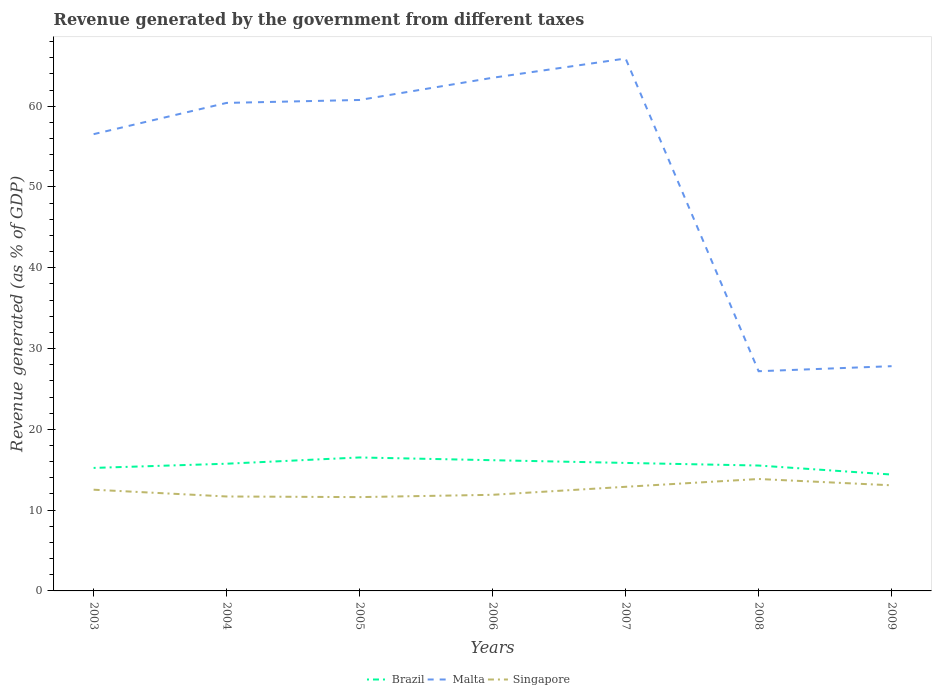How many different coloured lines are there?
Ensure brevity in your answer.  3. Does the line corresponding to Malta intersect with the line corresponding to Singapore?
Make the answer very short. No. Is the number of lines equal to the number of legend labels?
Offer a terse response. Yes. Across all years, what is the maximum revenue generated by the government in Singapore?
Ensure brevity in your answer.  11.61. In which year was the revenue generated by the government in Singapore maximum?
Provide a short and direct response. 2005. What is the total revenue generated by the government in Singapore in the graph?
Ensure brevity in your answer.  -0.96. What is the difference between the highest and the second highest revenue generated by the government in Malta?
Keep it short and to the point. 38.71. How many lines are there?
Your response must be concise. 3. How many years are there in the graph?
Your response must be concise. 7. Are the values on the major ticks of Y-axis written in scientific E-notation?
Provide a succinct answer. No. Does the graph contain grids?
Keep it short and to the point. No. What is the title of the graph?
Offer a terse response. Revenue generated by the government from different taxes. Does "Jamaica" appear as one of the legend labels in the graph?
Make the answer very short. No. What is the label or title of the Y-axis?
Ensure brevity in your answer.  Revenue generated (as % of GDP). What is the Revenue generated (as % of GDP) of Brazil in 2003?
Provide a succinct answer. 15.23. What is the Revenue generated (as % of GDP) in Malta in 2003?
Your answer should be compact. 56.54. What is the Revenue generated (as % of GDP) in Singapore in 2003?
Your answer should be very brief. 12.53. What is the Revenue generated (as % of GDP) in Brazil in 2004?
Your answer should be compact. 15.75. What is the Revenue generated (as % of GDP) in Malta in 2004?
Offer a terse response. 60.41. What is the Revenue generated (as % of GDP) in Singapore in 2004?
Keep it short and to the point. 11.69. What is the Revenue generated (as % of GDP) of Brazil in 2005?
Keep it short and to the point. 16.52. What is the Revenue generated (as % of GDP) of Malta in 2005?
Your answer should be very brief. 60.77. What is the Revenue generated (as % of GDP) of Singapore in 2005?
Your response must be concise. 11.61. What is the Revenue generated (as % of GDP) in Brazil in 2006?
Keep it short and to the point. 16.18. What is the Revenue generated (as % of GDP) of Malta in 2006?
Offer a terse response. 63.52. What is the Revenue generated (as % of GDP) of Singapore in 2006?
Offer a terse response. 11.9. What is the Revenue generated (as % of GDP) in Brazil in 2007?
Ensure brevity in your answer.  15.84. What is the Revenue generated (as % of GDP) in Malta in 2007?
Your answer should be very brief. 65.9. What is the Revenue generated (as % of GDP) in Singapore in 2007?
Offer a very short reply. 12.89. What is the Revenue generated (as % of GDP) in Brazil in 2008?
Ensure brevity in your answer.  15.52. What is the Revenue generated (as % of GDP) in Malta in 2008?
Your response must be concise. 27.19. What is the Revenue generated (as % of GDP) of Singapore in 2008?
Make the answer very short. 13.85. What is the Revenue generated (as % of GDP) of Brazil in 2009?
Provide a short and direct response. 14.4. What is the Revenue generated (as % of GDP) of Malta in 2009?
Your answer should be compact. 27.82. What is the Revenue generated (as % of GDP) of Singapore in 2009?
Your answer should be very brief. 13.07. Across all years, what is the maximum Revenue generated (as % of GDP) in Brazil?
Keep it short and to the point. 16.52. Across all years, what is the maximum Revenue generated (as % of GDP) in Malta?
Your answer should be very brief. 65.9. Across all years, what is the maximum Revenue generated (as % of GDP) of Singapore?
Your response must be concise. 13.85. Across all years, what is the minimum Revenue generated (as % of GDP) of Brazil?
Your answer should be compact. 14.4. Across all years, what is the minimum Revenue generated (as % of GDP) in Malta?
Keep it short and to the point. 27.19. Across all years, what is the minimum Revenue generated (as % of GDP) of Singapore?
Keep it short and to the point. 11.61. What is the total Revenue generated (as % of GDP) of Brazil in the graph?
Your response must be concise. 109.44. What is the total Revenue generated (as % of GDP) of Malta in the graph?
Make the answer very short. 362.15. What is the total Revenue generated (as % of GDP) of Singapore in the graph?
Offer a very short reply. 87.54. What is the difference between the Revenue generated (as % of GDP) in Brazil in 2003 and that in 2004?
Provide a short and direct response. -0.52. What is the difference between the Revenue generated (as % of GDP) in Malta in 2003 and that in 2004?
Give a very brief answer. -3.87. What is the difference between the Revenue generated (as % of GDP) of Singapore in 2003 and that in 2004?
Keep it short and to the point. 0.84. What is the difference between the Revenue generated (as % of GDP) in Brazil in 2003 and that in 2005?
Provide a succinct answer. -1.29. What is the difference between the Revenue generated (as % of GDP) of Malta in 2003 and that in 2005?
Offer a very short reply. -4.23. What is the difference between the Revenue generated (as % of GDP) of Singapore in 2003 and that in 2005?
Your response must be concise. 0.92. What is the difference between the Revenue generated (as % of GDP) in Brazil in 2003 and that in 2006?
Provide a short and direct response. -0.95. What is the difference between the Revenue generated (as % of GDP) in Malta in 2003 and that in 2006?
Your answer should be very brief. -6.98. What is the difference between the Revenue generated (as % of GDP) of Singapore in 2003 and that in 2006?
Your response must be concise. 0.63. What is the difference between the Revenue generated (as % of GDP) in Brazil in 2003 and that in 2007?
Give a very brief answer. -0.62. What is the difference between the Revenue generated (as % of GDP) in Malta in 2003 and that in 2007?
Your answer should be very brief. -9.36. What is the difference between the Revenue generated (as % of GDP) in Singapore in 2003 and that in 2007?
Offer a terse response. -0.36. What is the difference between the Revenue generated (as % of GDP) in Brazil in 2003 and that in 2008?
Offer a very short reply. -0.29. What is the difference between the Revenue generated (as % of GDP) in Malta in 2003 and that in 2008?
Offer a terse response. 29.34. What is the difference between the Revenue generated (as % of GDP) of Singapore in 2003 and that in 2008?
Ensure brevity in your answer.  -1.32. What is the difference between the Revenue generated (as % of GDP) of Brazil in 2003 and that in 2009?
Keep it short and to the point. 0.82. What is the difference between the Revenue generated (as % of GDP) of Malta in 2003 and that in 2009?
Keep it short and to the point. 28.72. What is the difference between the Revenue generated (as % of GDP) in Singapore in 2003 and that in 2009?
Your response must be concise. -0.54. What is the difference between the Revenue generated (as % of GDP) in Brazil in 2004 and that in 2005?
Provide a short and direct response. -0.78. What is the difference between the Revenue generated (as % of GDP) in Malta in 2004 and that in 2005?
Ensure brevity in your answer.  -0.36. What is the difference between the Revenue generated (as % of GDP) of Singapore in 2004 and that in 2005?
Your answer should be compact. 0.08. What is the difference between the Revenue generated (as % of GDP) of Brazil in 2004 and that in 2006?
Offer a terse response. -0.43. What is the difference between the Revenue generated (as % of GDP) of Malta in 2004 and that in 2006?
Ensure brevity in your answer.  -3.11. What is the difference between the Revenue generated (as % of GDP) of Singapore in 2004 and that in 2006?
Your response must be concise. -0.21. What is the difference between the Revenue generated (as % of GDP) in Brazil in 2004 and that in 2007?
Offer a terse response. -0.1. What is the difference between the Revenue generated (as % of GDP) in Malta in 2004 and that in 2007?
Ensure brevity in your answer.  -5.5. What is the difference between the Revenue generated (as % of GDP) of Singapore in 2004 and that in 2007?
Offer a terse response. -1.2. What is the difference between the Revenue generated (as % of GDP) in Brazil in 2004 and that in 2008?
Offer a terse response. 0.22. What is the difference between the Revenue generated (as % of GDP) in Malta in 2004 and that in 2008?
Your answer should be compact. 33.21. What is the difference between the Revenue generated (as % of GDP) of Singapore in 2004 and that in 2008?
Provide a succinct answer. -2.16. What is the difference between the Revenue generated (as % of GDP) of Brazil in 2004 and that in 2009?
Give a very brief answer. 1.34. What is the difference between the Revenue generated (as % of GDP) of Malta in 2004 and that in 2009?
Provide a short and direct response. 32.59. What is the difference between the Revenue generated (as % of GDP) of Singapore in 2004 and that in 2009?
Provide a short and direct response. -1.38. What is the difference between the Revenue generated (as % of GDP) of Brazil in 2005 and that in 2006?
Offer a terse response. 0.34. What is the difference between the Revenue generated (as % of GDP) of Malta in 2005 and that in 2006?
Your answer should be very brief. -2.75. What is the difference between the Revenue generated (as % of GDP) of Singapore in 2005 and that in 2006?
Offer a terse response. -0.29. What is the difference between the Revenue generated (as % of GDP) of Brazil in 2005 and that in 2007?
Offer a terse response. 0.68. What is the difference between the Revenue generated (as % of GDP) in Malta in 2005 and that in 2007?
Provide a short and direct response. -5.13. What is the difference between the Revenue generated (as % of GDP) of Singapore in 2005 and that in 2007?
Offer a very short reply. -1.28. What is the difference between the Revenue generated (as % of GDP) of Malta in 2005 and that in 2008?
Provide a succinct answer. 33.58. What is the difference between the Revenue generated (as % of GDP) in Singapore in 2005 and that in 2008?
Ensure brevity in your answer.  -2.24. What is the difference between the Revenue generated (as % of GDP) of Brazil in 2005 and that in 2009?
Provide a short and direct response. 2.12. What is the difference between the Revenue generated (as % of GDP) of Malta in 2005 and that in 2009?
Your response must be concise. 32.95. What is the difference between the Revenue generated (as % of GDP) in Singapore in 2005 and that in 2009?
Provide a succinct answer. -1.46. What is the difference between the Revenue generated (as % of GDP) in Brazil in 2006 and that in 2007?
Your answer should be very brief. 0.34. What is the difference between the Revenue generated (as % of GDP) of Malta in 2006 and that in 2007?
Keep it short and to the point. -2.38. What is the difference between the Revenue generated (as % of GDP) in Singapore in 2006 and that in 2007?
Your answer should be very brief. -0.99. What is the difference between the Revenue generated (as % of GDP) of Brazil in 2006 and that in 2008?
Your answer should be compact. 0.66. What is the difference between the Revenue generated (as % of GDP) of Malta in 2006 and that in 2008?
Keep it short and to the point. 36.32. What is the difference between the Revenue generated (as % of GDP) of Singapore in 2006 and that in 2008?
Your response must be concise. -1.96. What is the difference between the Revenue generated (as % of GDP) of Brazil in 2006 and that in 2009?
Make the answer very short. 1.78. What is the difference between the Revenue generated (as % of GDP) in Malta in 2006 and that in 2009?
Your response must be concise. 35.7. What is the difference between the Revenue generated (as % of GDP) of Singapore in 2006 and that in 2009?
Keep it short and to the point. -1.17. What is the difference between the Revenue generated (as % of GDP) in Brazil in 2007 and that in 2008?
Offer a terse response. 0.32. What is the difference between the Revenue generated (as % of GDP) in Malta in 2007 and that in 2008?
Offer a terse response. 38.71. What is the difference between the Revenue generated (as % of GDP) of Singapore in 2007 and that in 2008?
Provide a succinct answer. -0.96. What is the difference between the Revenue generated (as % of GDP) in Brazil in 2007 and that in 2009?
Your response must be concise. 1.44. What is the difference between the Revenue generated (as % of GDP) of Malta in 2007 and that in 2009?
Offer a terse response. 38.08. What is the difference between the Revenue generated (as % of GDP) of Singapore in 2007 and that in 2009?
Offer a very short reply. -0.18. What is the difference between the Revenue generated (as % of GDP) in Brazil in 2008 and that in 2009?
Make the answer very short. 1.12. What is the difference between the Revenue generated (as % of GDP) in Malta in 2008 and that in 2009?
Your response must be concise. -0.62. What is the difference between the Revenue generated (as % of GDP) in Singapore in 2008 and that in 2009?
Provide a succinct answer. 0.78. What is the difference between the Revenue generated (as % of GDP) of Brazil in 2003 and the Revenue generated (as % of GDP) of Malta in 2004?
Offer a terse response. -45.18. What is the difference between the Revenue generated (as % of GDP) of Brazil in 2003 and the Revenue generated (as % of GDP) of Singapore in 2004?
Provide a succinct answer. 3.54. What is the difference between the Revenue generated (as % of GDP) of Malta in 2003 and the Revenue generated (as % of GDP) of Singapore in 2004?
Offer a very short reply. 44.85. What is the difference between the Revenue generated (as % of GDP) in Brazil in 2003 and the Revenue generated (as % of GDP) in Malta in 2005?
Your response must be concise. -45.55. What is the difference between the Revenue generated (as % of GDP) in Brazil in 2003 and the Revenue generated (as % of GDP) in Singapore in 2005?
Give a very brief answer. 3.61. What is the difference between the Revenue generated (as % of GDP) in Malta in 2003 and the Revenue generated (as % of GDP) in Singapore in 2005?
Give a very brief answer. 44.93. What is the difference between the Revenue generated (as % of GDP) in Brazil in 2003 and the Revenue generated (as % of GDP) in Malta in 2006?
Give a very brief answer. -48.29. What is the difference between the Revenue generated (as % of GDP) of Brazil in 2003 and the Revenue generated (as % of GDP) of Singapore in 2006?
Keep it short and to the point. 3.33. What is the difference between the Revenue generated (as % of GDP) in Malta in 2003 and the Revenue generated (as % of GDP) in Singapore in 2006?
Provide a short and direct response. 44.64. What is the difference between the Revenue generated (as % of GDP) of Brazil in 2003 and the Revenue generated (as % of GDP) of Malta in 2007?
Offer a very short reply. -50.68. What is the difference between the Revenue generated (as % of GDP) of Brazil in 2003 and the Revenue generated (as % of GDP) of Singapore in 2007?
Offer a very short reply. 2.34. What is the difference between the Revenue generated (as % of GDP) of Malta in 2003 and the Revenue generated (as % of GDP) of Singapore in 2007?
Offer a very short reply. 43.65. What is the difference between the Revenue generated (as % of GDP) in Brazil in 2003 and the Revenue generated (as % of GDP) in Malta in 2008?
Offer a terse response. -11.97. What is the difference between the Revenue generated (as % of GDP) in Brazil in 2003 and the Revenue generated (as % of GDP) in Singapore in 2008?
Your answer should be very brief. 1.37. What is the difference between the Revenue generated (as % of GDP) of Malta in 2003 and the Revenue generated (as % of GDP) of Singapore in 2008?
Your answer should be very brief. 42.69. What is the difference between the Revenue generated (as % of GDP) in Brazil in 2003 and the Revenue generated (as % of GDP) in Malta in 2009?
Provide a succinct answer. -12.59. What is the difference between the Revenue generated (as % of GDP) in Brazil in 2003 and the Revenue generated (as % of GDP) in Singapore in 2009?
Your answer should be very brief. 2.15. What is the difference between the Revenue generated (as % of GDP) of Malta in 2003 and the Revenue generated (as % of GDP) of Singapore in 2009?
Your answer should be compact. 43.47. What is the difference between the Revenue generated (as % of GDP) in Brazil in 2004 and the Revenue generated (as % of GDP) in Malta in 2005?
Give a very brief answer. -45.03. What is the difference between the Revenue generated (as % of GDP) in Brazil in 2004 and the Revenue generated (as % of GDP) in Singapore in 2005?
Offer a very short reply. 4.13. What is the difference between the Revenue generated (as % of GDP) of Malta in 2004 and the Revenue generated (as % of GDP) of Singapore in 2005?
Offer a very short reply. 48.79. What is the difference between the Revenue generated (as % of GDP) in Brazil in 2004 and the Revenue generated (as % of GDP) in Malta in 2006?
Your response must be concise. -47.77. What is the difference between the Revenue generated (as % of GDP) of Brazil in 2004 and the Revenue generated (as % of GDP) of Singapore in 2006?
Give a very brief answer. 3.85. What is the difference between the Revenue generated (as % of GDP) in Malta in 2004 and the Revenue generated (as % of GDP) in Singapore in 2006?
Give a very brief answer. 48.51. What is the difference between the Revenue generated (as % of GDP) of Brazil in 2004 and the Revenue generated (as % of GDP) of Malta in 2007?
Make the answer very short. -50.16. What is the difference between the Revenue generated (as % of GDP) in Brazil in 2004 and the Revenue generated (as % of GDP) in Singapore in 2007?
Your response must be concise. 2.86. What is the difference between the Revenue generated (as % of GDP) in Malta in 2004 and the Revenue generated (as % of GDP) in Singapore in 2007?
Give a very brief answer. 47.52. What is the difference between the Revenue generated (as % of GDP) of Brazil in 2004 and the Revenue generated (as % of GDP) of Malta in 2008?
Your response must be concise. -11.45. What is the difference between the Revenue generated (as % of GDP) in Brazil in 2004 and the Revenue generated (as % of GDP) in Singapore in 2008?
Your response must be concise. 1.89. What is the difference between the Revenue generated (as % of GDP) in Malta in 2004 and the Revenue generated (as % of GDP) in Singapore in 2008?
Ensure brevity in your answer.  46.55. What is the difference between the Revenue generated (as % of GDP) in Brazil in 2004 and the Revenue generated (as % of GDP) in Malta in 2009?
Your answer should be compact. -12.07. What is the difference between the Revenue generated (as % of GDP) of Brazil in 2004 and the Revenue generated (as % of GDP) of Singapore in 2009?
Offer a terse response. 2.67. What is the difference between the Revenue generated (as % of GDP) of Malta in 2004 and the Revenue generated (as % of GDP) of Singapore in 2009?
Provide a succinct answer. 47.33. What is the difference between the Revenue generated (as % of GDP) of Brazil in 2005 and the Revenue generated (as % of GDP) of Malta in 2006?
Provide a succinct answer. -47. What is the difference between the Revenue generated (as % of GDP) in Brazil in 2005 and the Revenue generated (as % of GDP) in Singapore in 2006?
Provide a succinct answer. 4.62. What is the difference between the Revenue generated (as % of GDP) of Malta in 2005 and the Revenue generated (as % of GDP) of Singapore in 2006?
Your response must be concise. 48.87. What is the difference between the Revenue generated (as % of GDP) in Brazil in 2005 and the Revenue generated (as % of GDP) in Malta in 2007?
Offer a very short reply. -49.38. What is the difference between the Revenue generated (as % of GDP) in Brazil in 2005 and the Revenue generated (as % of GDP) in Singapore in 2007?
Your answer should be very brief. 3.63. What is the difference between the Revenue generated (as % of GDP) of Malta in 2005 and the Revenue generated (as % of GDP) of Singapore in 2007?
Provide a short and direct response. 47.88. What is the difference between the Revenue generated (as % of GDP) of Brazil in 2005 and the Revenue generated (as % of GDP) of Malta in 2008?
Make the answer very short. -10.67. What is the difference between the Revenue generated (as % of GDP) in Brazil in 2005 and the Revenue generated (as % of GDP) in Singapore in 2008?
Make the answer very short. 2.67. What is the difference between the Revenue generated (as % of GDP) of Malta in 2005 and the Revenue generated (as % of GDP) of Singapore in 2008?
Your response must be concise. 46.92. What is the difference between the Revenue generated (as % of GDP) of Brazil in 2005 and the Revenue generated (as % of GDP) of Malta in 2009?
Provide a short and direct response. -11.3. What is the difference between the Revenue generated (as % of GDP) of Brazil in 2005 and the Revenue generated (as % of GDP) of Singapore in 2009?
Make the answer very short. 3.45. What is the difference between the Revenue generated (as % of GDP) of Malta in 2005 and the Revenue generated (as % of GDP) of Singapore in 2009?
Your response must be concise. 47.7. What is the difference between the Revenue generated (as % of GDP) of Brazil in 2006 and the Revenue generated (as % of GDP) of Malta in 2007?
Your answer should be compact. -49.72. What is the difference between the Revenue generated (as % of GDP) in Brazil in 2006 and the Revenue generated (as % of GDP) in Singapore in 2007?
Ensure brevity in your answer.  3.29. What is the difference between the Revenue generated (as % of GDP) in Malta in 2006 and the Revenue generated (as % of GDP) in Singapore in 2007?
Provide a short and direct response. 50.63. What is the difference between the Revenue generated (as % of GDP) in Brazil in 2006 and the Revenue generated (as % of GDP) in Malta in 2008?
Your answer should be very brief. -11.01. What is the difference between the Revenue generated (as % of GDP) of Brazil in 2006 and the Revenue generated (as % of GDP) of Singapore in 2008?
Ensure brevity in your answer.  2.33. What is the difference between the Revenue generated (as % of GDP) in Malta in 2006 and the Revenue generated (as % of GDP) in Singapore in 2008?
Offer a very short reply. 49.66. What is the difference between the Revenue generated (as % of GDP) of Brazil in 2006 and the Revenue generated (as % of GDP) of Malta in 2009?
Keep it short and to the point. -11.64. What is the difference between the Revenue generated (as % of GDP) in Brazil in 2006 and the Revenue generated (as % of GDP) in Singapore in 2009?
Give a very brief answer. 3.11. What is the difference between the Revenue generated (as % of GDP) of Malta in 2006 and the Revenue generated (as % of GDP) of Singapore in 2009?
Make the answer very short. 50.45. What is the difference between the Revenue generated (as % of GDP) of Brazil in 2007 and the Revenue generated (as % of GDP) of Malta in 2008?
Provide a short and direct response. -11.35. What is the difference between the Revenue generated (as % of GDP) of Brazil in 2007 and the Revenue generated (as % of GDP) of Singapore in 2008?
Make the answer very short. 1.99. What is the difference between the Revenue generated (as % of GDP) of Malta in 2007 and the Revenue generated (as % of GDP) of Singapore in 2008?
Keep it short and to the point. 52.05. What is the difference between the Revenue generated (as % of GDP) in Brazil in 2007 and the Revenue generated (as % of GDP) in Malta in 2009?
Your answer should be compact. -11.97. What is the difference between the Revenue generated (as % of GDP) in Brazil in 2007 and the Revenue generated (as % of GDP) in Singapore in 2009?
Ensure brevity in your answer.  2.77. What is the difference between the Revenue generated (as % of GDP) in Malta in 2007 and the Revenue generated (as % of GDP) in Singapore in 2009?
Give a very brief answer. 52.83. What is the difference between the Revenue generated (as % of GDP) in Brazil in 2008 and the Revenue generated (as % of GDP) in Malta in 2009?
Keep it short and to the point. -12.3. What is the difference between the Revenue generated (as % of GDP) in Brazil in 2008 and the Revenue generated (as % of GDP) in Singapore in 2009?
Your answer should be compact. 2.45. What is the difference between the Revenue generated (as % of GDP) of Malta in 2008 and the Revenue generated (as % of GDP) of Singapore in 2009?
Offer a terse response. 14.12. What is the average Revenue generated (as % of GDP) of Brazil per year?
Your answer should be compact. 15.63. What is the average Revenue generated (as % of GDP) in Malta per year?
Your response must be concise. 51.74. What is the average Revenue generated (as % of GDP) of Singapore per year?
Your response must be concise. 12.51. In the year 2003, what is the difference between the Revenue generated (as % of GDP) in Brazil and Revenue generated (as % of GDP) in Malta?
Keep it short and to the point. -41.31. In the year 2003, what is the difference between the Revenue generated (as % of GDP) in Brazil and Revenue generated (as % of GDP) in Singapore?
Offer a very short reply. 2.7. In the year 2003, what is the difference between the Revenue generated (as % of GDP) in Malta and Revenue generated (as % of GDP) in Singapore?
Your answer should be very brief. 44.01. In the year 2004, what is the difference between the Revenue generated (as % of GDP) in Brazil and Revenue generated (as % of GDP) in Malta?
Provide a short and direct response. -44.66. In the year 2004, what is the difference between the Revenue generated (as % of GDP) in Brazil and Revenue generated (as % of GDP) in Singapore?
Give a very brief answer. 4.05. In the year 2004, what is the difference between the Revenue generated (as % of GDP) in Malta and Revenue generated (as % of GDP) in Singapore?
Your answer should be very brief. 48.72. In the year 2005, what is the difference between the Revenue generated (as % of GDP) in Brazil and Revenue generated (as % of GDP) in Malta?
Provide a succinct answer. -44.25. In the year 2005, what is the difference between the Revenue generated (as % of GDP) in Brazil and Revenue generated (as % of GDP) in Singapore?
Offer a very short reply. 4.91. In the year 2005, what is the difference between the Revenue generated (as % of GDP) in Malta and Revenue generated (as % of GDP) in Singapore?
Your answer should be compact. 49.16. In the year 2006, what is the difference between the Revenue generated (as % of GDP) in Brazil and Revenue generated (as % of GDP) in Malta?
Make the answer very short. -47.34. In the year 2006, what is the difference between the Revenue generated (as % of GDP) of Brazil and Revenue generated (as % of GDP) of Singapore?
Make the answer very short. 4.28. In the year 2006, what is the difference between the Revenue generated (as % of GDP) in Malta and Revenue generated (as % of GDP) in Singapore?
Give a very brief answer. 51.62. In the year 2007, what is the difference between the Revenue generated (as % of GDP) of Brazil and Revenue generated (as % of GDP) of Malta?
Give a very brief answer. -50.06. In the year 2007, what is the difference between the Revenue generated (as % of GDP) in Brazil and Revenue generated (as % of GDP) in Singapore?
Ensure brevity in your answer.  2.95. In the year 2007, what is the difference between the Revenue generated (as % of GDP) in Malta and Revenue generated (as % of GDP) in Singapore?
Provide a short and direct response. 53.01. In the year 2008, what is the difference between the Revenue generated (as % of GDP) of Brazil and Revenue generated (as % of GDP) of Malta?
Your answer should be compact. -11.67. In the year 2008, what is the difference between the Revenue generated (as % of GDP) in Brazil and Revenue generated (as % of GDP) in Singapore?
Provide a short and direct response. 1.67. In the year 2008, what is the difference between the Revenue generated (as % of GDP) in Malta and Revenue generated (as % of GDP) in Singapore?
Your answer should be compact. 13.34. In the year 2009, what is the difference between the Revenue generated (as % of GDP) in Brazil and Revenue generated (as % of GDP) in Malta?
Keep it short and to the point. -13.41. In the year 2009, what is the difference between the Revenue generated (as % of GDP) in Brazil and Revenue generated (as % of GDP) in Singapore?
Provide a short and direct response. 1.33. In the year 2009, what is the difference between the Revenue generated (as % of GDP) in Malta and Revenue generated (as % of GDP) in Singapore?
Give a very brief answer. 14.75. What is the ratio of the Revenue generated (as % of GDP) of Brazil in 2003 to that in 2004?
Provide a short and direct response. 0.97. What is the ratio of the Revenue generated (as % of GDP) in Malta in 2003 to that in 2004?
Keep it short and to the point. 0.94. What is the ratio of the Revenue generated (as % of GDP) in Singapore in 2003 to that in 2004?
Offer a terse response. 1.07. What is the ratio of the Revenue generated (as % of GDP) of Brazil in 2003 to that in 2005?
Your response must be concise. 0.92. What is the ratio of the Revenue generated (as % of GDP) of Malta in 2003 to that in 2005?
Your answer should be very brief. 0.93. What is the ratio of the Revenue generated (as % of GDP) of Singapore in 2003 to that in 2005?
Provide a short and direct response. 1.08. What is the ratio of the Revenue generated (as % of GDP) of Brazil in 2003 to that in 2006?
Offer a very short reply. 0.94. What is the ratio of the Revenue generated (as % of GDP) of Malta in 2003 to that in 2006?
Offer a terse response. 0.89. What is the ratio of the Revenue generated (as % of GDP) of Singapore in 2003 to that in 2006?
Make the answer very short. 1.05. What is the ratio of the Revenue generated (as % of GDP) of Malta in 2003 to that in 2007?
Ensure brevity in your answer.  0.86. What is the ratio of the Revenue generated (as % of GDP) of Singapore in 2003 to that in 2007?
Your answer should be very brief. 0.97. What is the ratio of the Revenue generated (as % of GDP) of Malta in 2003 to that in 2008?
Ensure brevity in your answer.  2.08. What is the ratio of the Revenue generated (as % of GDP) of Singapore in 2003 to that in 2008?
Keep it short and to the point. 0.9. What is the ratio of the Revenue generated (as % of GDP) of Brazil in 2003 to that in 2009?
Keep it short and to the point. 1.06. What is the ratio of the Revenue generated (as % of GDP) in Malta in 2003 to that in 2009?
Your answer should be compact. 2.03. What is the ratio of the Revenue generated (as % of GDP) in Singapore in 2003 to that in 2009?
Provide a short and direct response. 0.96. What is the ratio of the Revenue generated (as % of GDP) in Brazil in 2004 to that in 2005?
Provide a succinct answer. 0.95. What is the ratio of the Revenue generated (as % of GDP) of Malta in 2004 to that in 2005?
Make the answer very short. 0.99. What is the ratio of the Revenue generated (as % of GDP) in Brazil in 2004 to that in 2006?
Your answer should be compact. 0.97. What is the ratio of the Revenue generated (as % of GDP) in Malta in 2004 to that in 2006?
Ensure brevity in your answer.  0.95. What is the ratio of the Revenue generated (as % of GDP) in Singapore in 2004 to that in 2006?
Ensure brevity in your answer.  0.98. What is the ratio of the Revenue generated (as % of GDP) of Malta in 2004 to that in 2007?
Offer a terse response. 0.92. What is the ratio of the Revenue generated (as % of GDP) of Singapore in 2004 to that in 2007?
Your answer should be very brief. 0.91. What is the ratio of the Revenue generated (as % of GDP) in Brazil in 2004 to that in 2008?
Keep it short and to the point. 1.01. What is the ratio of the Revenue generated (as % of GDP) of Malta in 2004 to that in 2008?
Make the answer very short. 2.22. What is the ratio of the Revenue generated (as % of GDP) of Singapore in 2004 to that in 2008?
Give a very brief answer. 0.84. What is the ratio of the Revenue generated (as % of GDP) of Brazil in 2004 to that in 2009?
Give a very brief answer. 1.09. What is the ratio of the Revenue generated (as % of GDP) in Malta in 2004 to that in 2009?
Offer a terse response. 2.17. What is the ratio of the Revenue generated (as % of GDP) in Singapore in 2004 to that in 2009?
Keep it short and to the point. 0.89. What is the ratio of the Revenue generated (as % of GDP) of Brazil in 2005 to that in 2006?
Ensure brevity in your answer.  1.02. What is the ratio of the Revenue generated (as % of GDP) of Malta in 2005 to that in 2006?
Your answer should be very brief. 0.96. What is the ratio of the Revenue generated (as % of GDP) in Singapore in 2005 to that in 2006?
Give a very brief answer. 0.98. What is the ratio of the Revenue generated (as % of GDP) of Brazil in 2005 to that in 2007?
Give a very brief answer. 1.04. What is the ratio of the Revenue generated (as % of GDP) of Malta in 2005 to that in 2007?
Your answer should be compact. 0.92. What is the ratio of the Revenue generated (as % of GDP) in Singapore in 2005 to that in 2007?
Your answer should be very brief. 0.9. What is the ratio of the Revenue generated (as % of GDP) of Brazil in 2005 to that in 2008?
Make the answer very short. 1.06. What is the ratio of the Revenue generated (as % of GDP) of Malta in 2005 to that in 2008?
Provide a short and direct response. 2.23. What is the ratio of the Revenue generated (as % of GDP) of Singapore in 2005 to that in 2008?
Give a very brief answer. 0.84. What is the ratio of the Revenue generated (as % of GDP) in Brazil in 2005 to that in 2009?
Ensure brevity in your answer.  1.15. What is the ratio of the Revenue generated (as % of GDP) in Malta in 2005 to that in 2009?
Keep it short and to the point. 2.18. What is the ratio of the Revenue generated (as % of GDP) in Singapore in 2005 to that in 2009?
Your response must be concise. 0.89. What is the ratio of the Revenue generated (as % of GDP) in Brazil in 2006 to that in 2007?
Ensure brevity in your answer.  1.02. What is the ratio of the Revenue generated (as % of GDP) in Malta in 2006 to that in 2007?
Your response must be concise. 0.96. What is the ratio of the Revenue generated (as % of GDP) of Brazil in 2006 to that in 2008?
Ensure brevity in your answer.  1.04. What is the ratio of the Revenue generated (as % of GDP) of Malta in 2006 to that in 2008?
Your response must be concise. 2.34. What is the ratio of the Revenue generated (as % of GDP) in Singapore in 2006 to that in 2008?
Offer a very short reply. 0.86. What is the ratio of the Revenue generated (as % of GDP) in Brazil in 2006 to that in 2009?
Your response must be concise. 1.12. What is the ratio of the Revenue generated (as % of GDP) of Malta in 2006 to that in 2009?
Offer a terse response. 2.28. What is the ratio of the Revenue generated (as % of GDP) in Singapore in 2006 to that in 2009?
Your response must be concise. 0.91. What is the ratio of the Revenue generated (as % of GDP) in Brazil in 2007 to that in 2008?
Offer a very short reply. 1.02. What is the ratio of the Revenue generated (as % of GDP) of Malta in 2007 to that in 2008?
Your response must be concise. 2.42. What is the ratio of the Revenue generated (as % of GDP) of Singapore in 2007 to that in 2008?
Make the answer very short. 0.93. What is the ratio of the Revenue generated (as % of GDP) in Malta in 2007 to that in 2009?
Make the answer very short. 2.37. What is the ratio of the Revenue generated (as % of GDP) in Singapore in 2007 to that in 2009?
Give a very brief answer. 0.99. What is the ratio of the Revenue generated (as % of GDP) of Brazil in 2008 to that in 2009?
Offer a very short reply. 1.08. What is the ratio of the Revenue generated (as % of GDP) in Malta in 2008 to that in 2009?
Make the answer very short. 0.98. What is the ratio of the Revenue generated (as % of GDP) in Singapore in 2008 to that in 2009?
Keep it short and to the point. 1.06. What is the difference between the highest and the second highest Revenue generated (as % of GDP) in Brazil?
Provide a short and direct response. 0.34. What is the difference between the highest and the second highest Revenue generated (as % of GDP) of Malta?
Offer a very short reply. 2.38. What is the difference between the highest and the second highest Revenue generated (as % of GDP) of Singapore?
Give a very brief answer. 0.78. What is the difference between the highest and the lowest Revenue generated (as % of GDP) in Brazil?
Ensure brevity in your answer.  2.12. What is the difference between the highest and the lowest Revenue generated (as % of GDP) in Malta?
Make the answer very short. 38.71. What is the difference between the highest and the lowest Revenue generated (as % of GDP) of Singapore?
Give a very brief answer. 2.24. 